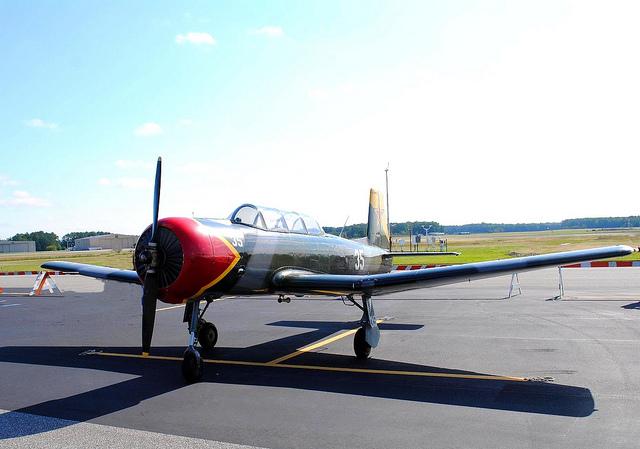Is the propeller spinning?
Quick response, please. No. What colors is this small plane?
Keep it brief. Red and black. Is the sky clear?
Short answer required. Yes. Does the plane look new?
Write a very short answer. No. 